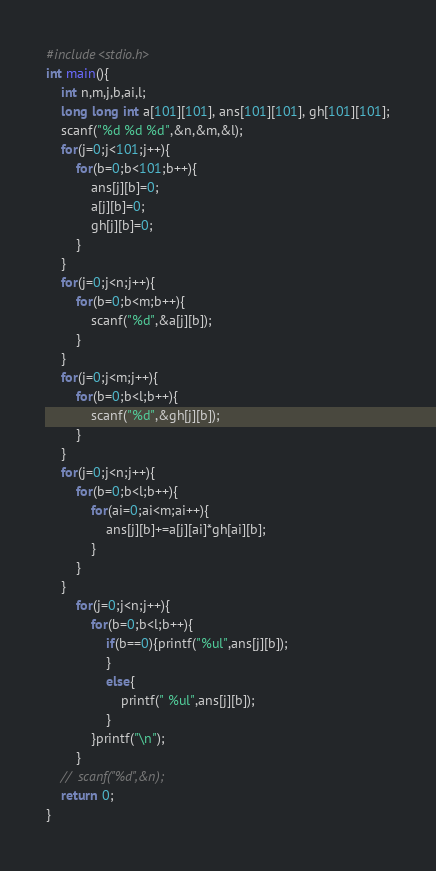<code> <loc_0><loc_0><loc_500><loc_500><_C_>#include<stdio.h>
int main(){
	int n,m,j,b,ai,l;
	long long int a[101][101], ans[101][101], gh[101][101];
	scanf("%d %d %d",&n,&m,&l);
	for(j=0;j<101;j++){
		for(b=0;b<101;b++){
			ans[j][b]=0;
			a[j][b]=0;
			gh[j][b]=0;
		}
	}
	for(j=0;j<n;j++){
		for(b=0;b<m;b++){
			scanf("%d",&a[j][b]);
		}
	}
	for(j=0;j<m;j++){
		for(b=0;b<l;b++){
			scanf("%d",&gh[j][b]);
		}
	}
	for(j=0;j<n;j++){
		for(b=0;b<l;b++){
			for(ai=0;ai<m;ai++){
				ans[j][b]+=a[j][ai]*gh[ai][b];
			}
		}
	}
		for(j=0;j<n;j++){
			for(b=0;b<l;b++){
				if(b==0){printf("%ul",ans[j][b]);
				}
				else{
					printf(" %ul",ans[j][b]);
				}
			}printf("\n");
		}
	//	scanf("%d",&n);
	return 0;
}</code> 